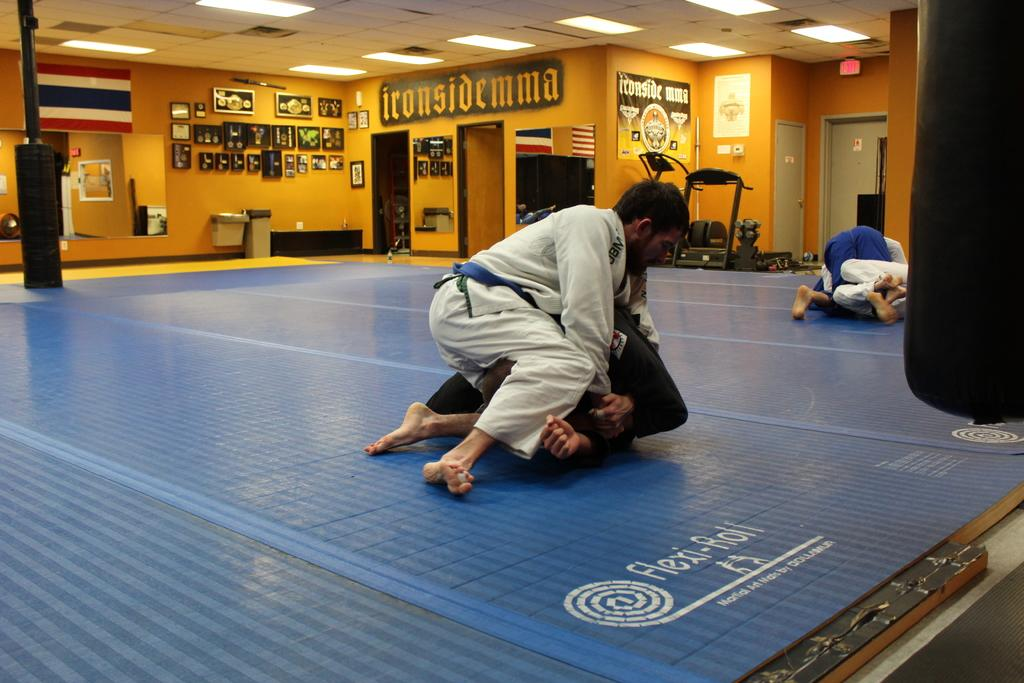What is happening between the two men in the image? There are two men fighting on the floor in the image. What can be seen in the background of the image? There is a mirror in the background of the image. What is the mirror reflecting in the image? Objects are reflecting in the mirror in the image. What is above the scene in the image? There is a ceiling in the image. What is providing illumination in the image? Lights are present in the image. What type of furniture can be seen in the image? There is no furniture present in the image; it primarily features the two men fighting and the mirror in the background. 